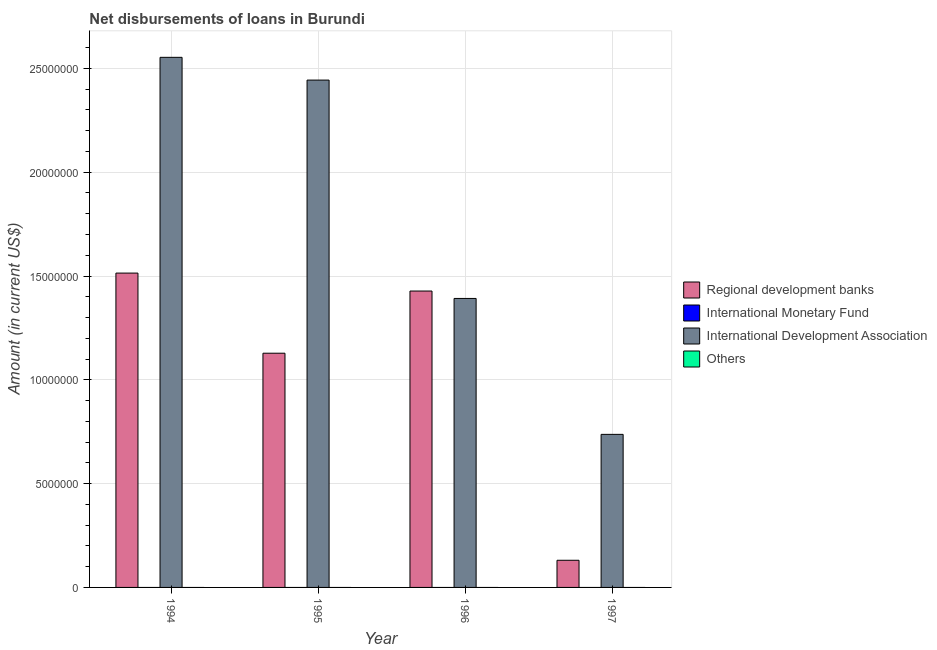How many groups of bars are there?
Provide a succinct answer. 4. How many bars are there on the 4th tick from the left?
Ensure brevity in your answer.  2. How many bars are there on the 1st tick from the right?
Give a very brief answer. 2. What is the label of the 3rd group of bars from the left?
Make the answer very short. 1996. In how many cases, is the number of bars for a given year not equal to the number of legend labels?
Your answer should be very brief. 4. Across all years, what is the maximum amount of loan disimbursed by international development association?
Your answer should be compact. 2.55e+07. Across all years, what is the minimum amount of loan disimbursed by regional development banks?
Keep it short and to the point. 1.31e+06. What is the total amount of loan disimbursed by international development association in the graph?
Provide a short and direct response. 7.13e+07. What is the difference between the amount of loan disimbursed by regional development banks in 1996 and that in 1997?
Provide a short and direct response. 1.30e+07. What is the average amount of loan disimbursed by international development association per year?
Offer a terse response. 1.78e+07. What is the ratio of the amount of loan disimbursed by regional development banks in 1994 to that in 1995?
Offer a terse response. 1.34. Is the amount of loan disimbursed by international development association in 1994 less than that in 1996?
Provide a short and direct response. No. What is the difference between the highest and the second highest amount of loan disimbursed by regional development banks?
Ensure brevity in your answer.  8.65e+05. What is the difference between the highest and the lowest amount of loan disimbursed by international development association?
Provide a succinct answer. 1.82e+07. Is it the case that in every year, the sum of the amount of loan disimbursed by regional development banks and amount of loan disimbursed by international monetary fund is greater than the amount of loan disimbursed by international development association?
Your answer should be very brief. No. How many bars are there?
Ensure brevity in your answer.  8. How many years are there in the graph?
Provide a succinct answer. 4. Does the graph contain grids?
Keep it short and to the point. Yes. How are the legend labels stacked?
Offer a terse response. Vertical. What is the title of the graph?
Your answer should be compact. Net disbursements of loans in Burundi. What is the label or title of the X-axis?
Keep it short and to the point. Year. What is the Amount (in current US$) in Regional development banks in 1994?
Offer a terse response. 1.51e+07. What is the Amount (in current US$) in International Development Association in 1994?
Make the answer very short. 2.55e+07. What is the Amount (in current US$) in Others in 1994?
Your answer should be compact. 0. What is the Amount (in current US$) in Regional development banks in 1995?
Your answer should be very brief. 1.13e+07. What is the Amount (in current US$) in International Monetary Fund in 1995?
Ensure brevity in your answer.  0. What is the Amount (in current US$) of International Development Association in 1995?
Offer a terse response. 2.44e+07. What is the Amount (in current US$) in Others in 1995?
Ensure brevity in your answer.  0. What is the Amount (in current US$) in Regional development banks in 1996?
Provide a succinct answer. 1.43e+07. What is the Amount (in current US$) of International Monetary Fund in 1996?
Offer a very short reply. 0. What is the Amount (in current US$) in International Development Association in 1996?
Your response must be concise. 1.39e+07. What is the Amount (in current US$) of Regional development banks in 1997?
Offer a very short reply. 1.31e+06. What is the Amount (in current US$) of International Monetary Fund in 1997?
Your answer should be compact. 0. What is the Amount (in current US$) of International Development Association in 1997?
Keep it short and to the point. 7.37e+06. What is the Amount (in current US$) in Others in 1997?
Ensure brevity in your answer.  0. Across all years, what is the maximum Amount (in current US$) in Regional development banks?
Your answer should be very brief. 1.51e+07. Across all years, what is the maximum Amount (in current US$) of International Development Association?
Ensure brevity in your answer.  2.55e+07. Across all years, what is the minimum Amount (in current US$) in Regional development banks?
Make the answer very short. 1.31e+06. Across all years, what is the minimum Amount (in current US$) in International Development Association?
Keep it short and to the point. 7.37e+06. What is the total Amount (in current US$) in Regional development banks in the graph?
Your response must be concise. 4.20e+07. What is the total Amount (in current US$) in International Development Association in the graph?
Your answer should be very brief. 7.13e+07. What is the difference between the Amount (in current US$) in Regional development banks in 1994 and that in 1995?
Your answer should be compact. 3.86e+06. What is the difference between the Amount (in current US$) in International Development Association in 1994 and that in 1995?
Make the answer very short. 1.10e+06. What is the difference between the Amount (in current US$) of Regional development banks in 1994 and that in 1996?
Give a very brief answer. 8.65e+05. What is the difference between the Amount (in current US$) of International Development Association in 1994 and that in 1996?
Offer a terse response. 1.16e+07. What is the difference between the Amount (in current US$) of Regional development banks in 1994 and that in 1997?
Give a very brief answer. 1.38e+07. What is the difference between the Amount (in current US$) in International Development Association in 1994 and that in 1997?
Keep it short and to the point. 1.82e+07. What is the difference between the Amount (in current US$) of Regional development banks in 1995 and that in 1996?
Provide a succinct answer. -3.00e+06. What is the difference between the Amount (in current US$) of International Development Association in 1995 and that in 1996?
Your answer should be very brief. 1.05e+07. What is the difference between the Amount (in current US$) in Regional development banks in 1995 and that in 1997?
Provide a short and direct response. 9.97e+06. What is the difference between the Amount (in current US$) of International Development Association in 1995 and that in 1997?
Give a very brief answer. 1.71e+07. What is the difference between the Amount (in current US$) of Regional development banks in 1996 and that in 1997?
Keep it short and to the point. 1.30e+07. What is the difference between the Amount (in current US$) in International Development Association in 1996 and that in 1997?
Give a very brief answer. 6.55e+06. What is the difference between the Amount (in current US$) in Regional development banks in 1994 and the Amount (in current US$) in International Development Association in 1995?
Offer a very short reply. -9.30e+06. What is the difference between the Amount (in current US$) in Regional development banks in 1994 and the Amount (in current US$) in International Development Association in 1996?
Provide a short and direct response. 1.22e+06. What is the difference between the Amount (in current US$) in Regional development banks in 1994 and the Amount (in current US$) in International Development Association in 1997?
Your answer should be compact. 7.77e+06. What is the difference between the Amount (in current US$) in Regional development banks in 1995 and the Amount (in current US$) in International Development Association in 1996?
Your answer should be very brief. -2.64e+06. What is the difference between the Amount (in current US$) of Regional development banks in 1995 and the Amount (in current US$) of International Development Association in 1997?
Keep it short and to the point. 3.91e+06. What is the difference between the Amount (in current US$) in Regional development banks in 1996 and the Amount (in current US$) in International Development Association in 1997?
Provide a short and direct response. 6.90e+06. What is the average Amount (in current US$) of Regional development banks per year?
Ensure brevity in your answer.  1.05e+07. What is the average Amount (in current US$) of International Monetary Fund per year?
Make the answer very short. 0. What is the average Amount (in current US$) of International Development Association per year?
Your answer should be compact. 1.78e+07. In the year 1994, what is the difference between the Amount (in current US$) of Regional development banks and Amount (in current US$) of International Development Association?
Your answer should be very brief. -1.04e+07. In the year 1995, what is the difference between the Amount (in current US$) in Regional development banks and Amount (in current US$) in International Development Association?
Offer a terse response. -1.32e+07. In the year 1996, what is the difference between the Amount (in current US$) in Regional development banks and Amount (in current US$) in International Development Association?
Provide a short and direct response. 3.57e+05. In the year 1997, what is the difference between the Amount (in current US$) of Regional development banks and Amount (in current US$) of International Development Association?
Your response must be concise. -6.06e+06. What is the ratio of the Amount (in current US$) in Regional development banks in 1994 to that in 1995?
Keep it short and to the point. 1.34. What is the ratio of the Amount (in current US$) in International Development Association in 1994 to that in 1995?
Offer a terse response. 1.04. What is the ratio of the Amount (in current US$) of Regional development banks in 1994 to that in 1996?
Provide a short and direct response. 1.06. What is the ratio of the Amount (in current US$) in International Development Association in 1994 to that in 1996?
Offer a terse response. 1.83. What is the ratio of the Amount (in current US$) of Regional development banks in 1994 to that in 1997?
Give a very brief answer. 11.58. What is the ratio of the Amount (in current US$) in International Development Association in 1994 to that in 1997?
Ensure brevity in your answer.  3.46. What is the ratio of the Amount (in current US$) of Regional development banks in 1995 to that in 1996?
Provide a short and direct response. 0.79. What is the ratio of the Amount (in current US$) of International Development Association in 1995 to that in 1996?
Provide a succinct answer. 1.76. What is the ratio of the Amount (in current US$) in Regional development banks in 1995 to that in 1997?
Provide a succinct answer. 8.63. What is the ratio of the Amount (in current US$) of International Development Association in 1995 to that in 1997?
Your response must be concise. 3.31. What is the ratio of the Amount (in current US$) in Regional development banks in 1996 to that in 1997?
Ensure brevity in your answer.  10.92. What is the ratio of the Amount (in current US$) of International Development Association in 1996 to that in 1997?
Provide a succinct answer. 1.89. What is the difference between the highest and the second highest Amount (in current US$) in Regional development banks?
Make the answer very short. 8.65e+05. What is the difference between the highest and the second highest Amount (in current US$) of International Development Association?
Ensure brevity in your answer.  1.10e+06. What is the difference between the highest and the lowest Amount (in current US$) of Regional development banks?
Provide a succinct answer. 1.38e+07. What is the difference between the highest and the lowest Amount (in current US$) in International Development Association?
Your answer should be compact. 1.82e+07. 